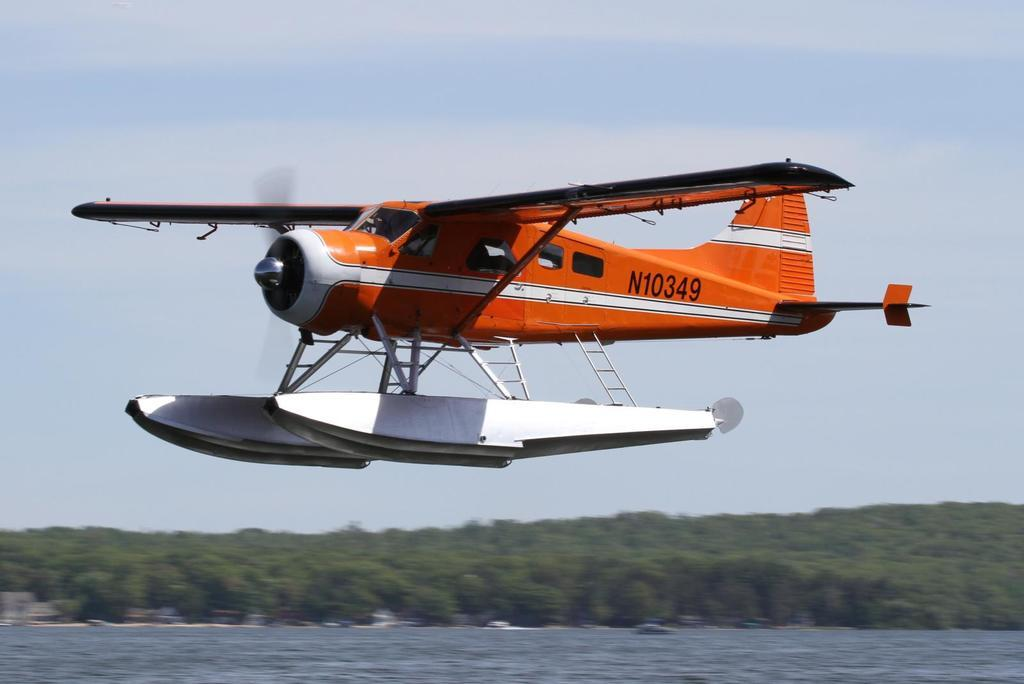<image>
Share a concise interpretation of the image provided. N10349 orange and white airplane over the water, 